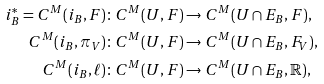<formula> <loc_0><loc_0><loc_500><loc_500>i _ { B } ^ { * } = C ^ { M } ( i _ { B } , F ) & \colon C ^ { M } ( U , F ) \to C ^ { M } ( U \cap E _ { B } , F ) , \\ C ^ { M } ( i _ { B } , \pi _ { V } ) & \colon C ^ { M } ( U , F ) \to C ^ { M } ( U \cap E _ { B } , F _ { V } ) , \\ C ^ { M } ( i _ { B } , \ell ) & \colon C ^ { M } ( U , F ) \to C ^ { M } ( U \cap E _ { B } , \mathbb { R } ) ,</formula> 